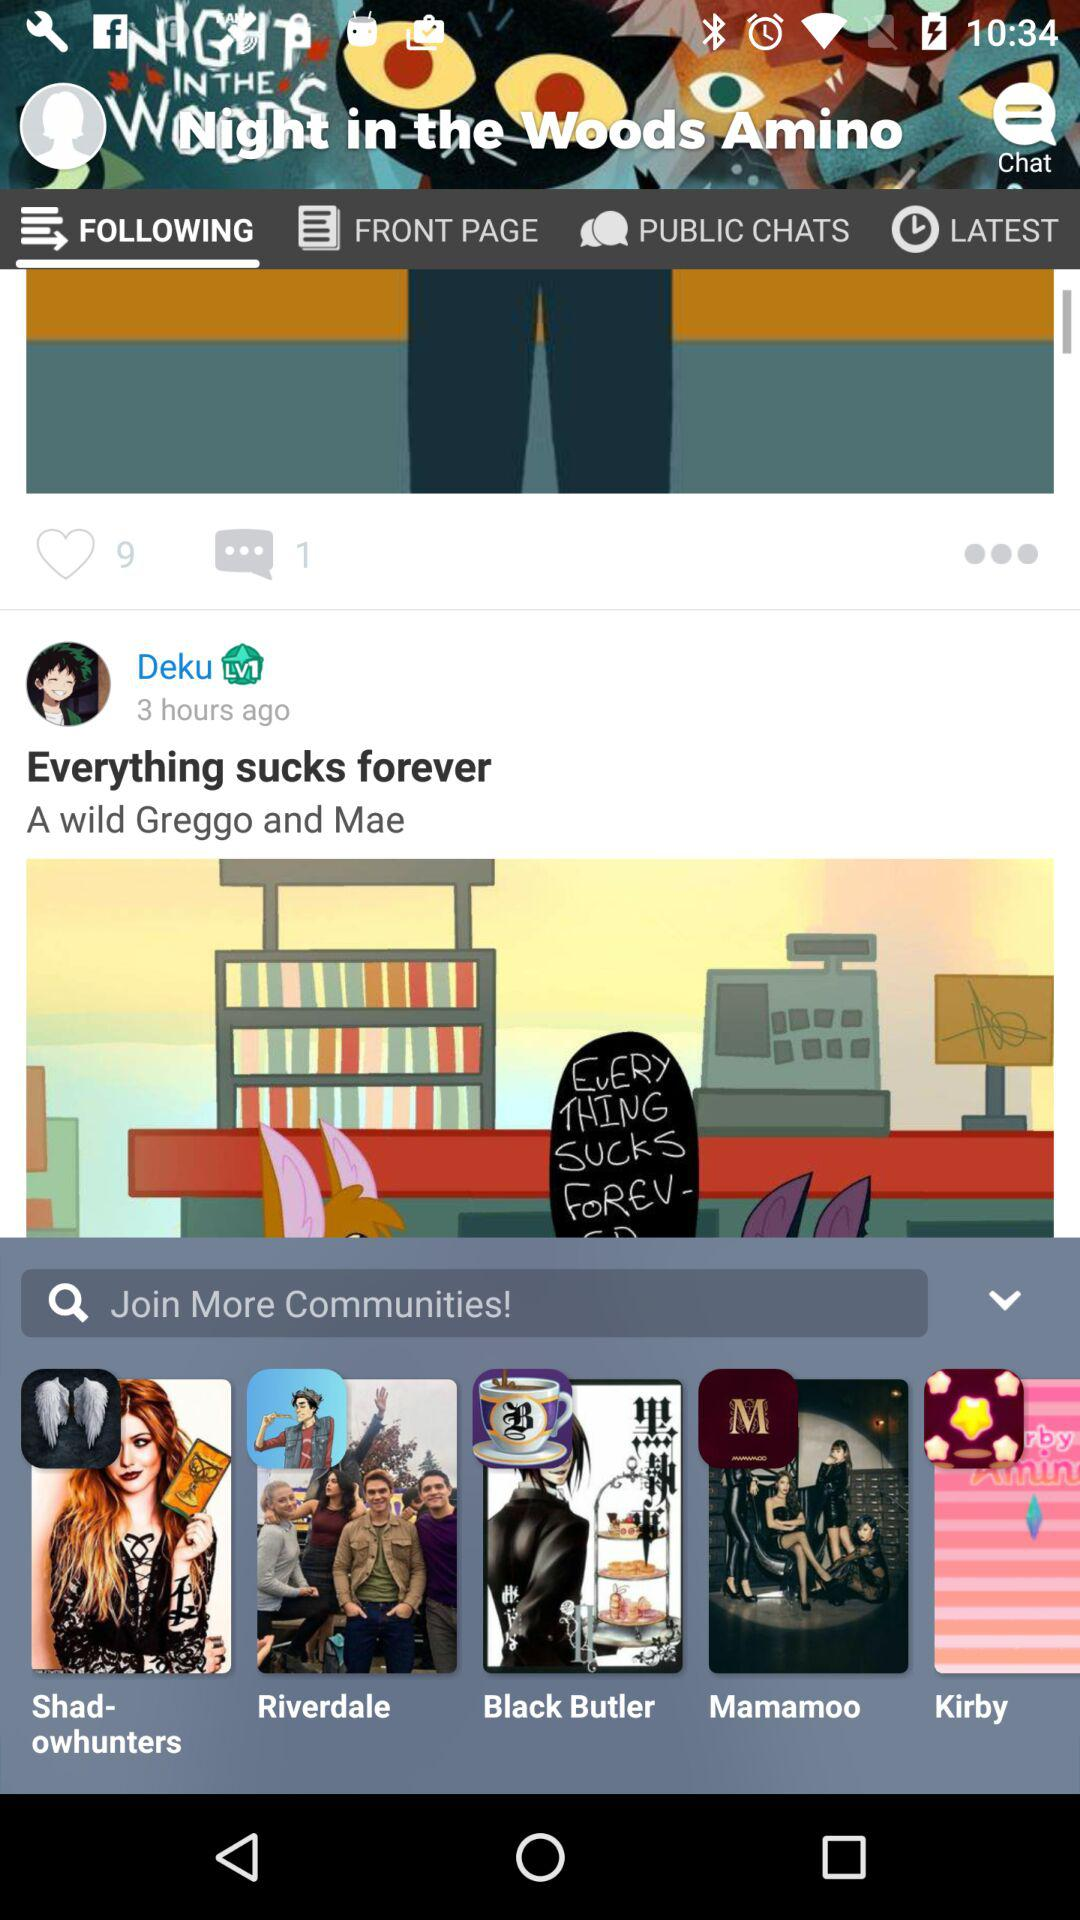How many likes are there of the post? There are 9 likes of the post. 